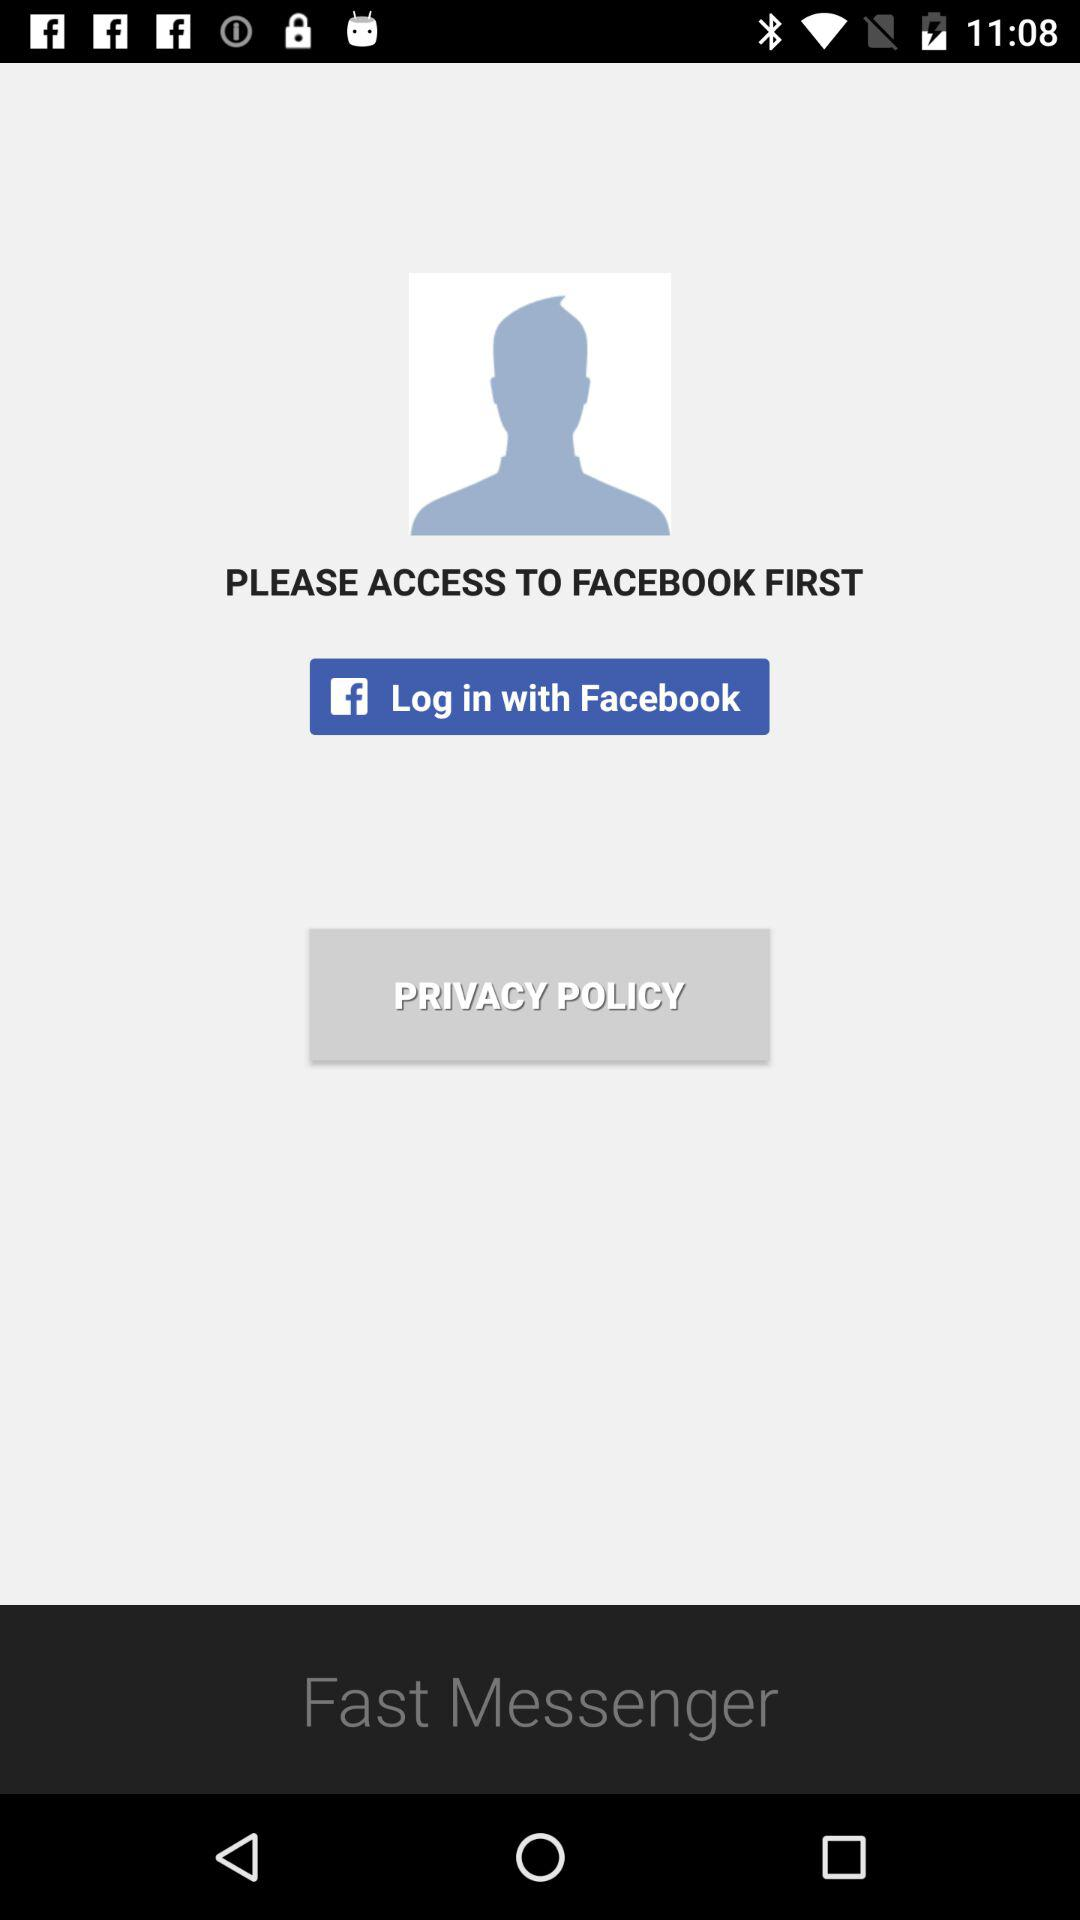Through what application can the user log in? The user can log in through "Facebook". 